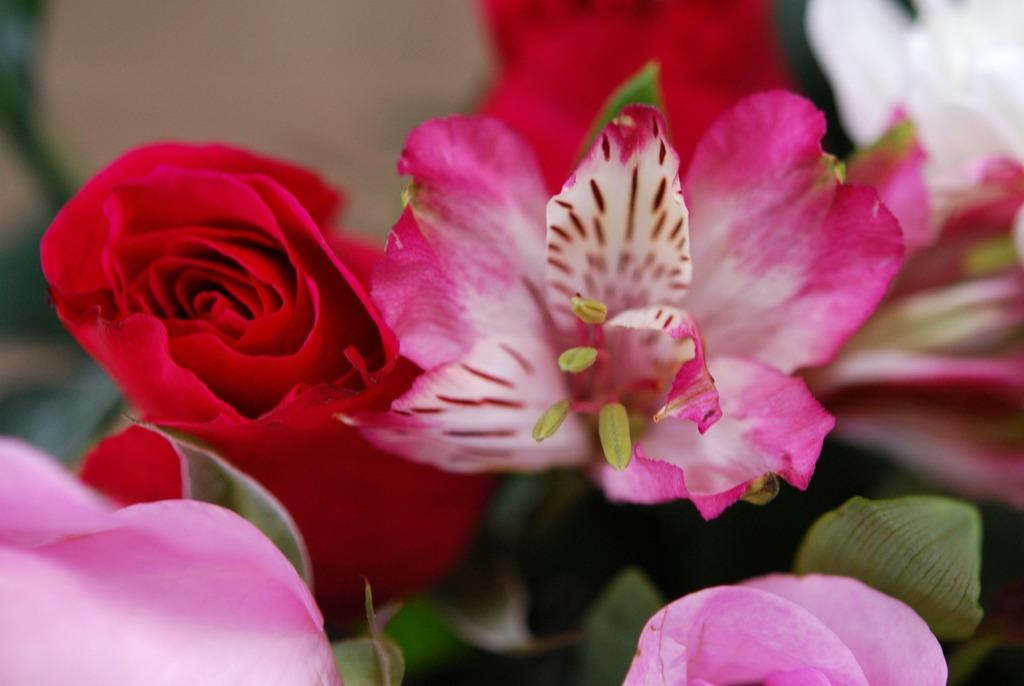What type of living organisms can be seen in the image? Flowers are visible in the image. What type of stone can be seen supporting the flowers in the image? There is no stone present in the image; only flowers are visible. What type of iron structure can be seen in the background of the image? There is no iron structure present in the image; only flowers are visible. 